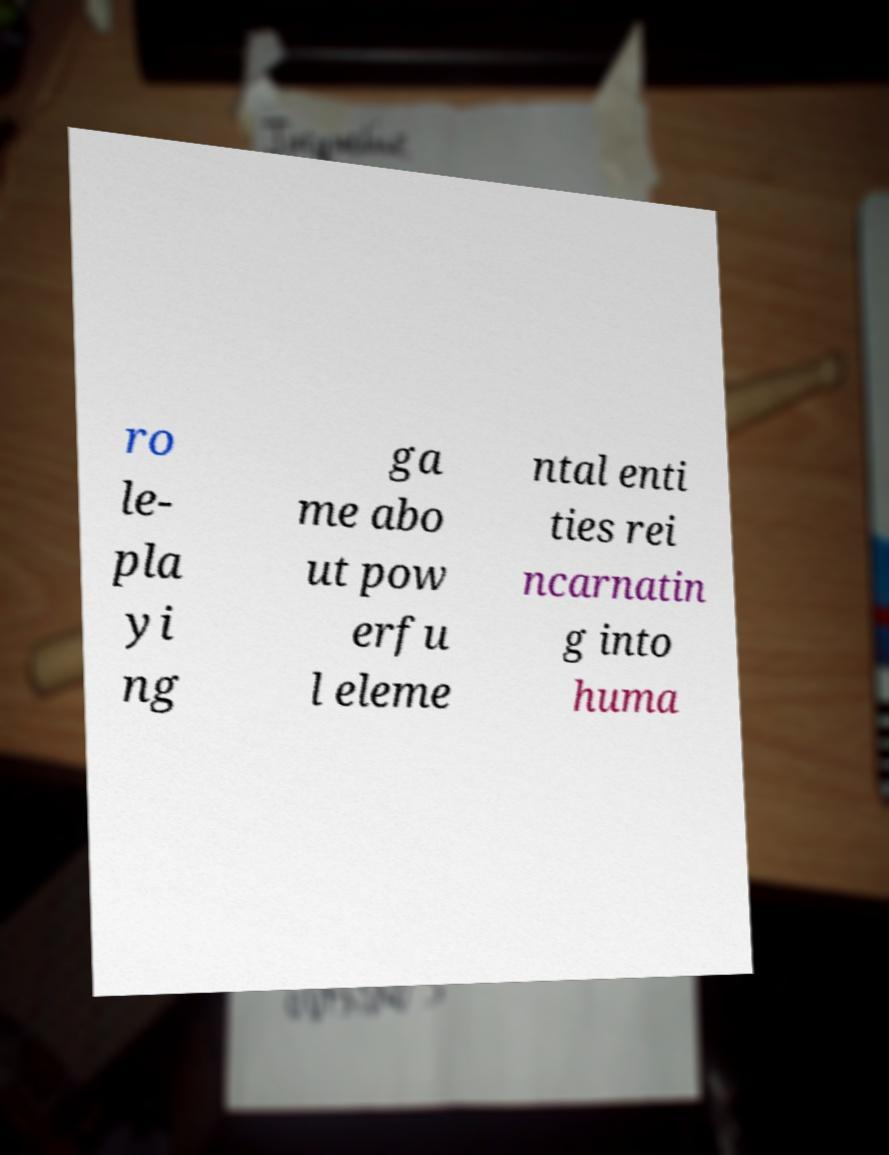For documentation purposes, I need the text within this image transcribed. Could you provide that? ro le- pla yi ng ga me abo ut pow erfu l eleme ntal enti ties rei ncarnatin g into huma 